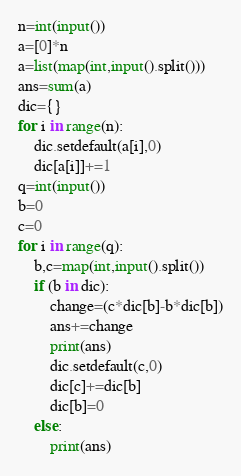Convert code to text. <code><loc_0><loc_0><loc_500><loc_500><_Python_>n=int(input())
a=[0]*n
a=list(map(int,input().split()))
ans=sum(a)
dic={}
for i in range(n):
    dic.setdefault(a[i],0)
    dic[a[i]]+=1
q=int(input())
b=0
c=0
for i in range(q):
    b,c=map(int,input().split())
    if (b in dic):
        change=(c*dic[b]-b*dic[b])
        ans+=change
        print(ans)
        dic.setdefault(c,0)
        dic[c]+=dic[b]
        dic[b]=0
    else:
      	print(ans)	</code> 